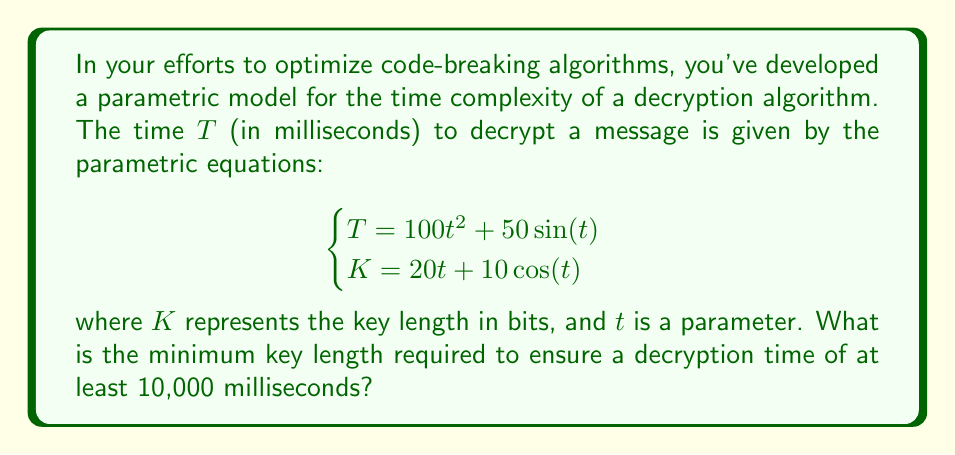Help me with this question. To solve this problem, we need to follow these steps:

1) First, we need to find the value of $t$ that corresponds to $T = 10,000$ ms.

2) The equation for $T$ is:

   $$T = 100t^2 + 50\sin(t)$$

3) We're looking for the smallest $t$ that satisfies:

   $$10000 \leq 100t^2 + 50\sin(t)$$

4) This is a transcendental equation and cannot be solved algebraically. We need to use numerical methods or graphing to find the solution.

5) Using a graphing calculator or computer software, we can find that the smallest positive value of $t$ that satisfies this inequality is approximately $t \approx 10$.

6) Now that we have $t$, we can use the equation for $K$ to find the corresponding key length:

   $$K = 20t + 10\cos(t)$$

7) Substituting $t = 10$:

   $$K = 20(10) + 10\cos(10)$$
   $$K = 200 + 10\cos(10)$$

8) Using a calculator, we find:

   $$K \approx 200 - 8.39 = 191.61$$

9) Since the key length must be an integer number of bits, we round up to the nearest whole number.
Answer: The minimum key length required is 192 bits. 